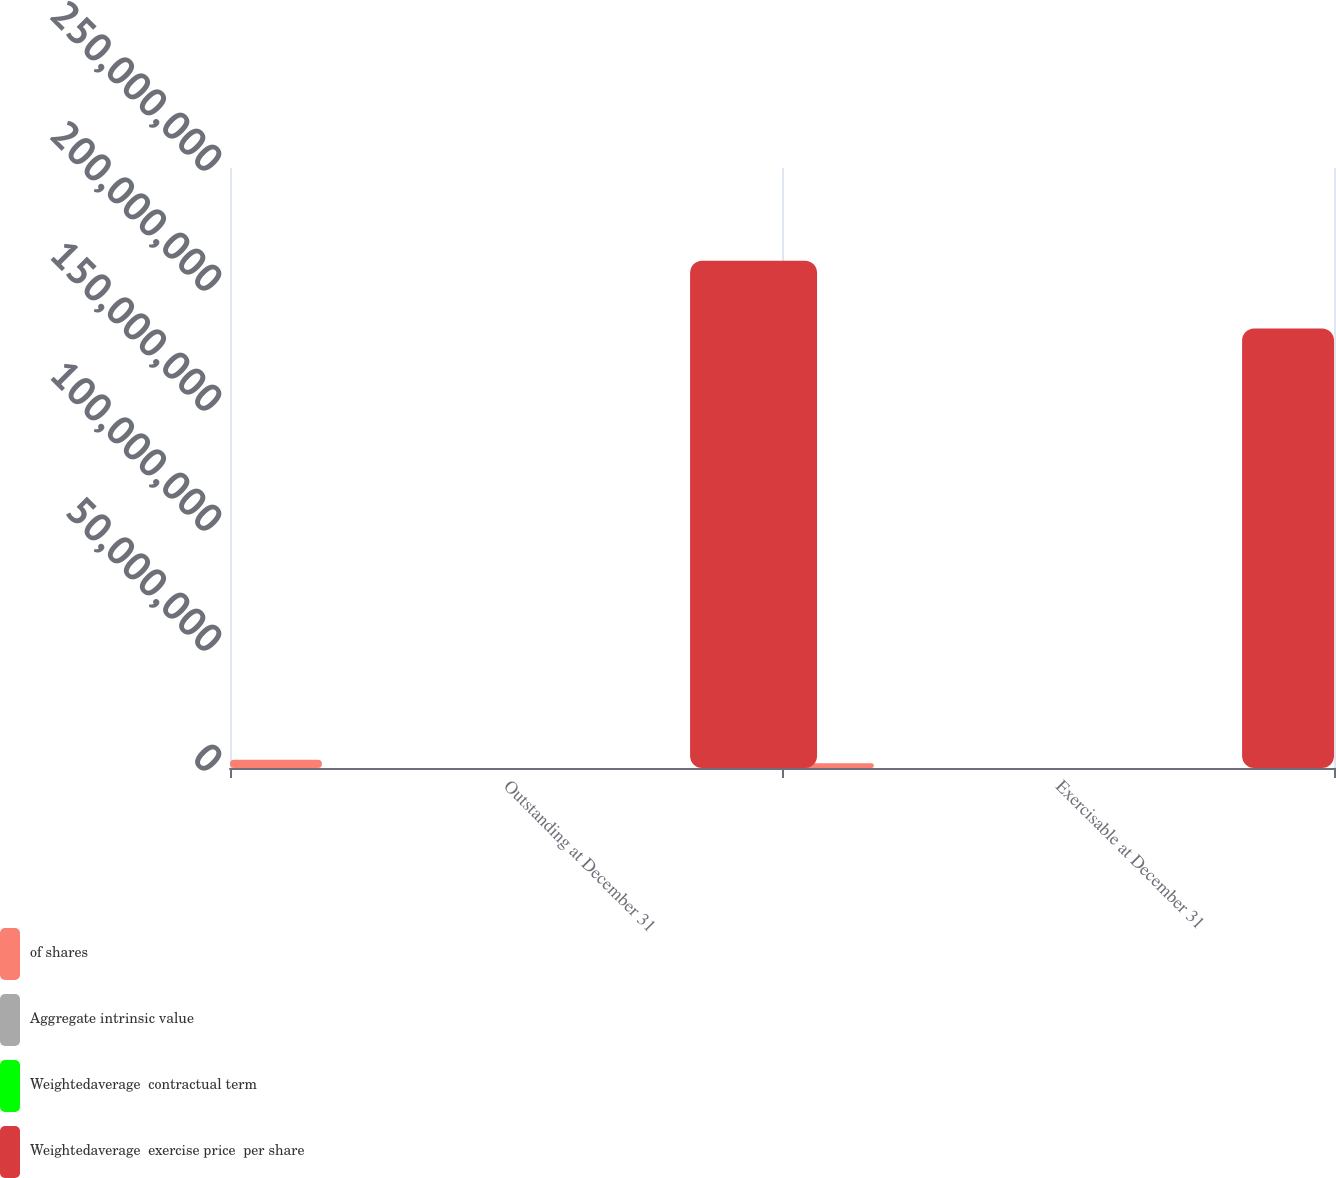Convert chart to OTSL. <chart><loc_0><loc_0><loc_500><loc_500><stacked_bar_chart><ecel><fcel>Outstanding at December 31<fcel>Exercisable at December 31<nl><fcel>of shares<fcel>3.4196e+06<fcel>1.95431e+06<nl><fcel>Aggregate intrinsic value<fcel>121.31<fcel>89.37<nl><fcel>Weightedaverage  contractual term<fcel>6.15<fcel>4.28<nl><fcel>Weightedaverage  exercise price  per share<fcel>2.1137e+08<fcel>1.83136e+08<nl></chart> 